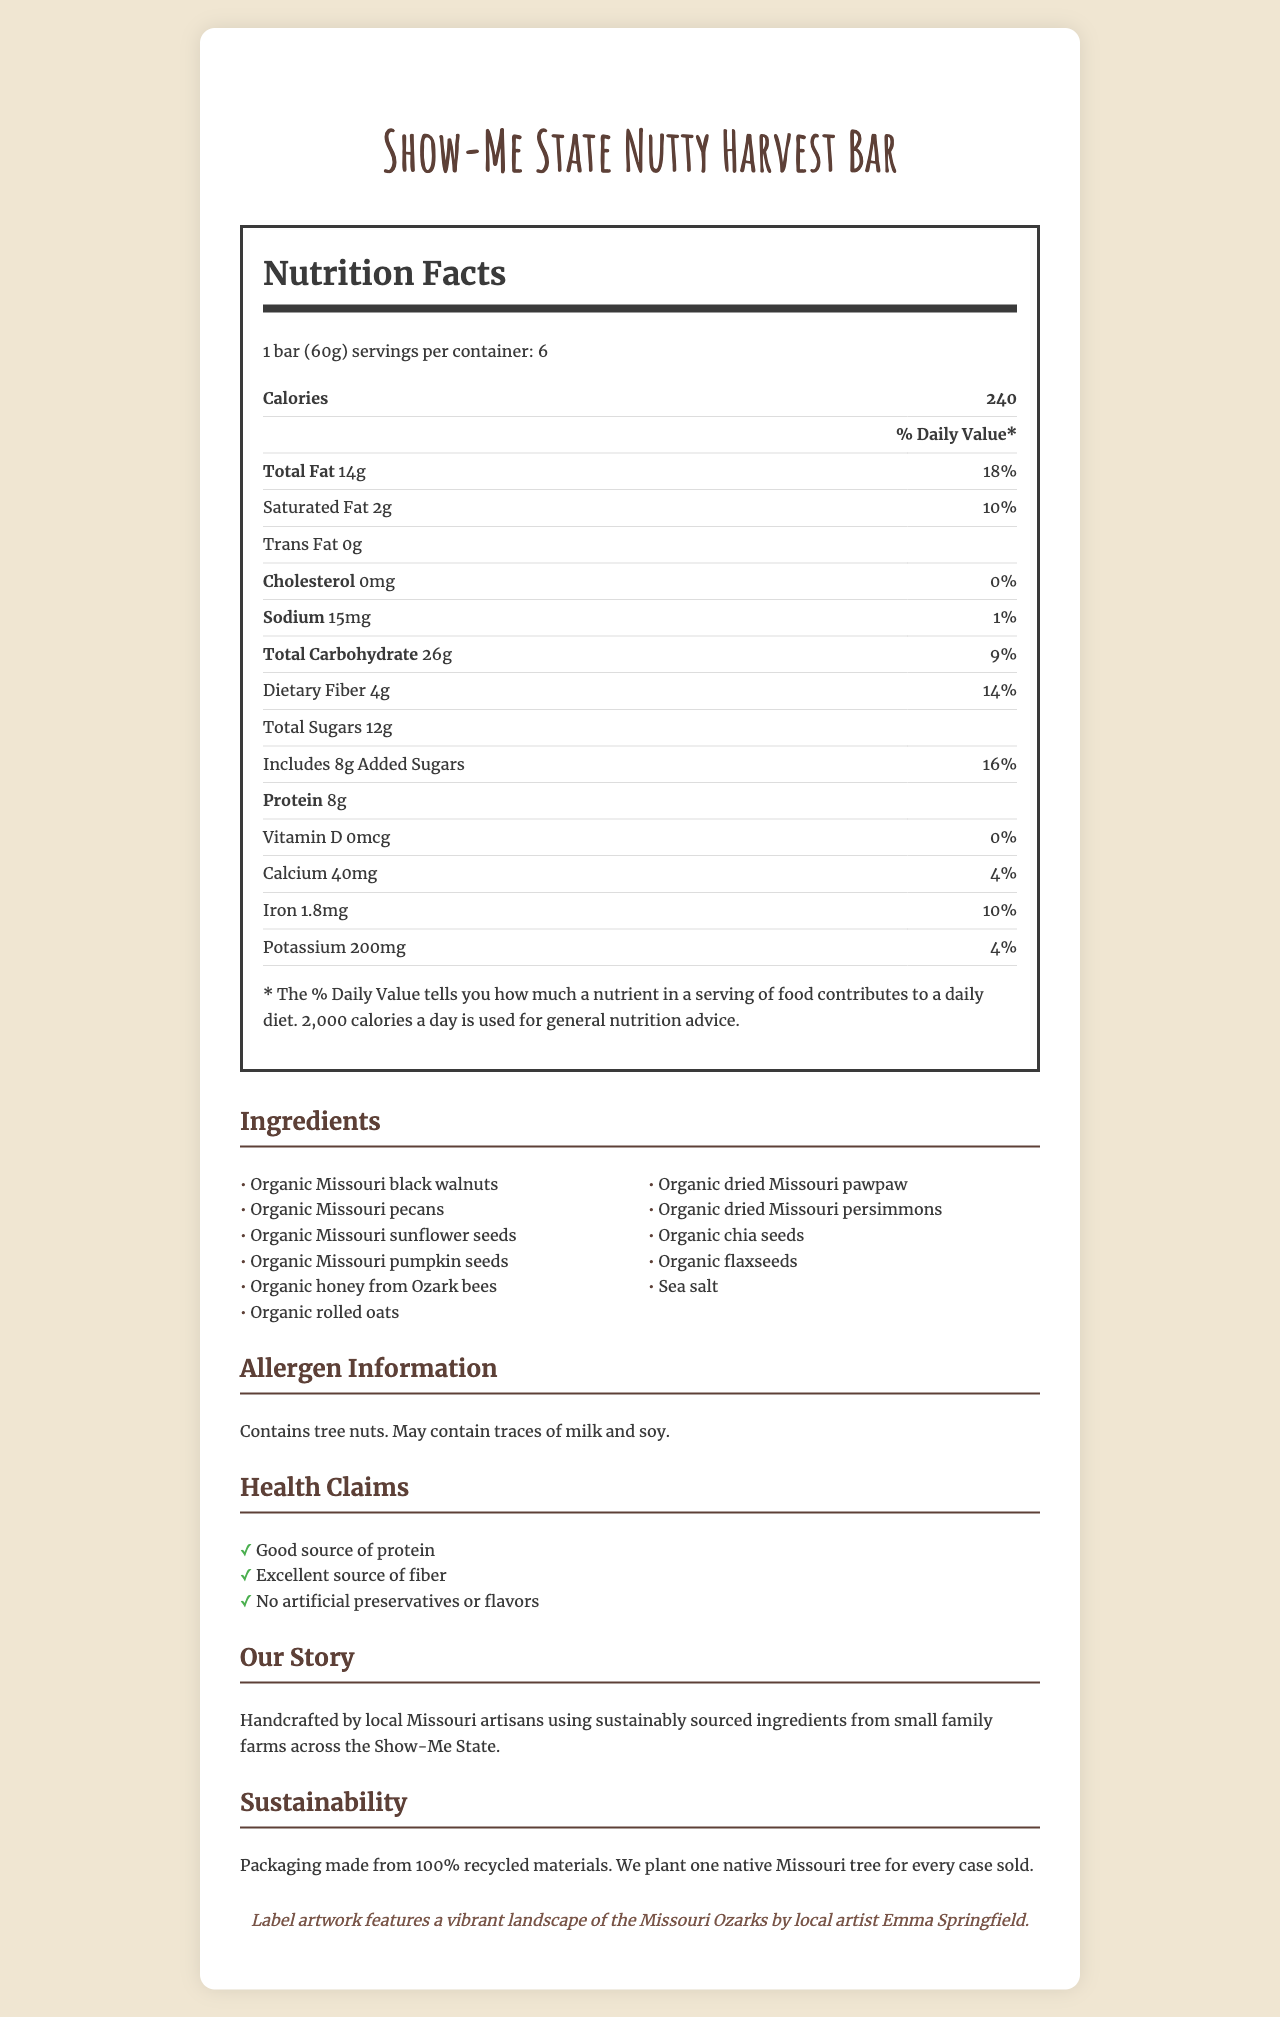how many servings per container does the Show-Me State Nutty Harvest Bar have? The document states that there are 6 servings per container.
Answer: 6 what is the amount of total fat per serving? The nutrition label indicates that there are 14g of total fat per serving.
Answer: 14g how much dietary fiber is in one serving of the energy bar? The document shows that one serving contains 4g of dietary fiber.
Answer: 4g are there any artificial preservatives or flavors in the Nutty Harvest Bar? The health claims section clearly states that there are no artificial preservatives or flavors.
Answer: No list at least three native Missouri ingredients included in the energy bar. Multiple ingredients listed in the ingredients section are native to Missouri, including black walnuts, pecans, and sunflower seeds.
Answer: Organic Missouri black walnuts, Organic Missouri pecans, Organic Missouri sunflower seeds what is the main source of sweetness in the energy bar? A. Cane Sugar B. Organic Honey from Ozark Bees C. Maple Syrup D. Molasses The ingredients list mentions that organic honey from Ozark bees is used, which is the main source of sweetness.
Answer: B which nutrient contributes the highest percentage to the daily value per serving? A. Total Fat B. Dietary Fiber C. Protein D. Calcium The total fat contributes 18% to the daily value, which is the highest percentage listed.
Answer: A is the Show-Me State Nutty Harvest Bar suitable for someone with a tree nut allergy? The allergen information section states that the bar contains tree nuts.
Answer: No summarize the main features and benefits of the Show-Me State Nutty Harvest Bar. The main features and benefits include the use of native Missouri ingredients, high nutritional value (protein and fiber), lack of artificial substances, sustainable practices, and local artistry.
Answer: The Show-Me State Nutty Harvest Bar is a handmade, farm-to-table energy bar featuring native Missouri nuts and seeds. It is a good source of protein and an excellent source of fiber, with no artificial preservatives or flavors. It is crafted by local Missouri artisans using sustainably sourced ingredients and packaged in recycled materials. For every case sold, a tree is planted in Missouri. The label art is designed by local artist Emma Springfield. how much vitamin D is in one serving of the energy bar? The nutrition label indicates that one serving contains 0mcg of vitamin D.
Answer: 0mcg what is the daily value percentage of added sugars in one serving? The nutrition label states that the added sugars contribute 16% to the daily value.
Answer: 16% which of the following best describes the sustainability initiative of the brand? A. The packaging is biodegradable B. The brand funds renewable energy projects C. They plant one native Missouri tree for every case sold D. They use solar panels in production The sustainability section mentions that they plant one native Missouri tree for every case sold.
Answer: C who is the artist behind the label artwork? The artist collaboration section indicates that the label artwork is by local artist Emma Springfield.
Answer: Emma Springfield where is the organic honey in the bar sourced from? The ingredients list specifies that the organic honey is from Ozark bees.
Answer: Ozark bees how many grams of trans fat are in the Show-Me State Nutty Harvest Bar? The nutrition label confirms that there are 0g of trans fat per serving.
Answer: 0g does the bar contain any milk or soy ingredients? The allergen section states that it may contain traces of milk and soy.
Answer: May contain traces what inspired the creation of the Show-Me State Nutty Harvest Bar? The document does not provide specific details about the inspiration behind creating the bar.
Answer: Not enough information 